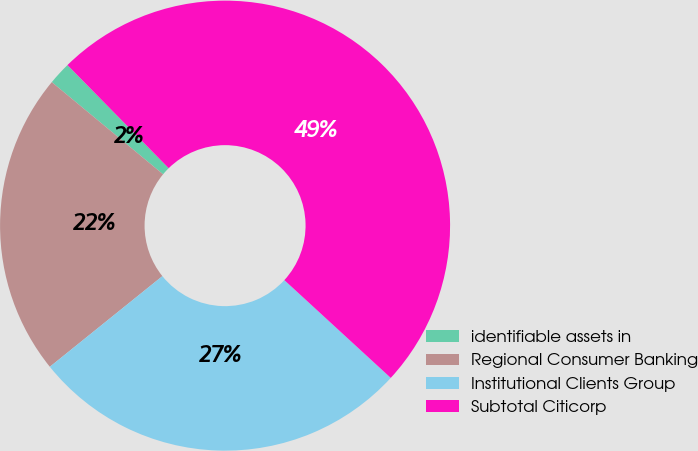<chart> <loc_0><loc_0><loc_500><loc_500><pie_chart><fcel>identifiable assets in<fcel>Regional Consumer Banking<fcel>Institutional Clients Group<fcel>Subtotal Citicorp<nl><fcel>1.64%<fcel>21.8%<fcel>27.38%<fcel>49.18%<nl></chart> 